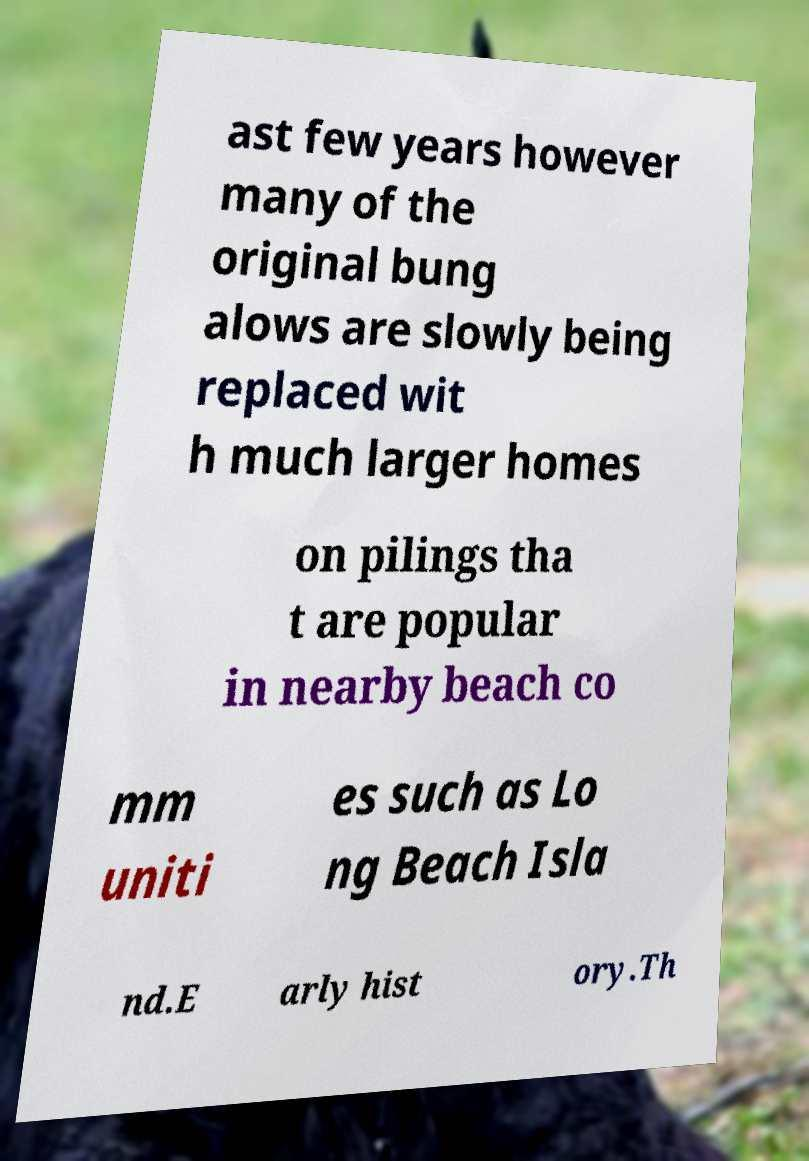Could you extract and type out the text from this image? ast few years however many of the original bung alows are slowly being replaced wit h much larger homes on pilings tha t are popular in nearby beach co mm uniti es such as Lo ng Beach Isla nd.E arly hist ory.Th 